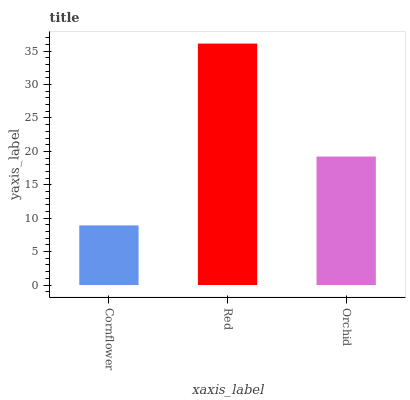Is Orchid the minimum?
Answer yes or no. No. Is Orchid the maximum?
Answer yes or no. No. Is Red greater than Orchid?
Answer yes or no. Yes. Is Orchid less than Red?
Answer yes or no. Yes. Is Orchid greater than Red?
Answer yes or no. No. Is Red less than Orchid?
Answer yes or no. No. Is Orchid the high median?
Answer yes or no. Yes. Is Orchid the low median?
Answer yes or no. Yes. Is Cornflower the high median?
Answer yes or no. No. Is Red the low median?
Answer yes or no. No. 